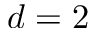Convert formula to latex. <formula><loc_0><loc_0><loc_500><loc_500>d = 2</formula> 